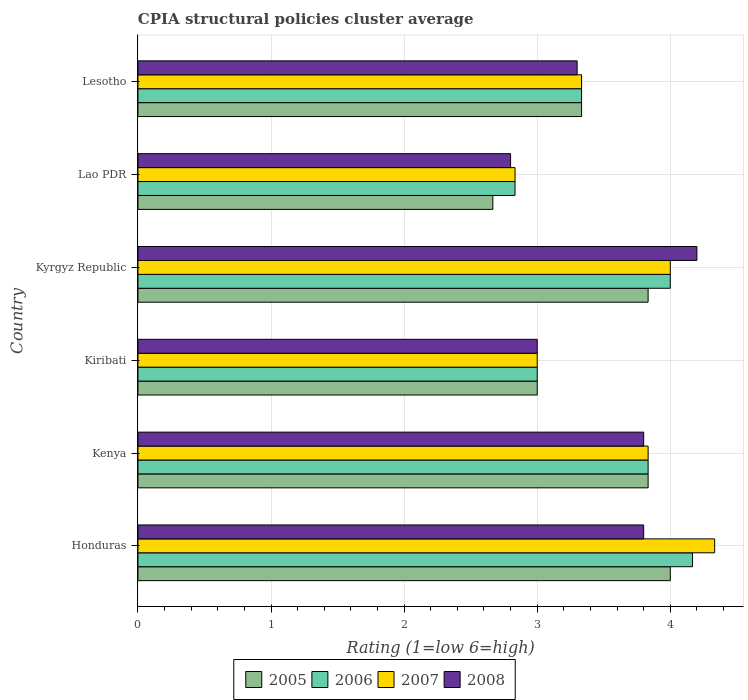How many different coloured bars are there?
Make the answer very short. 4. How many bars are there on the 4th tick from the bottom?
Keep it short and to the point. 4. What is the label of the 1st group of bars from the top?
Provide a succinct answer. Lesotho. In how many cases, is the number of bars for a given country not equal to the number of legend labels?
Your answer should be very brief. 0. What is the CPIA rating in 2007 in Kyrgyz Republic?
Provide a short and direct response. 4. Across all countries, what is the maximum CPIA rating in 2006?
Keep it short and to the point. 4.17. Across all countries, what is the minimum CPIA rating in 2007?
Offer a terse response. 2.83. In which country was the CPIA rating in 2006 maximum?
Give a very brief answer. Honduras. In which country was the CPIA rating in 2007 minimum?
Provide a short and direct response. Lao PDR. What is the total CPIA rating in 2007 in the graph?
Offer a very short reply. 21.33. What is the difference between the CPIA rating in 2006 in Kenya and that in Lesotho?
Give a very brief answer. 0.5. What is the average CPIA rating in 2005 per country?
Ensure brevity in your answer.  3.44. What is the difference between the CPIA rating in 2007 and CPIA rating in 2005 in Kenya?
Your answer should be compact. 0. What is the ratio of the CPIA rating in 2007 in Kiribati to that in Lao PDR?
Offer a very short reply. 1.06. Is the CPIA rating in 2008 in Honduras less than that in Kyrgyz Republic?
Your answer should be very brief. Yes. What is the difference between the highest and the second highest CPIA rating in 2005?
Your answer should be compact. 0.17. What is the difference between the highest and the lowest CPIA rating in 2006?
Keep it short and to the point. 1.33. Is the sum of the CPIA rating in 2005 in Kyrgyz Republic and Lao PDR greater than the maximum CPIA rating in 2008 across all countries?
Provide a succinct answer. Yes. Is it the case that in every country, the sum of the CPIA rating in 2006 and CPIA rating in 2008 is greater than the sum of CPIA rating in 2007 and CPIA rating in 2005?
Your answer should be compact. No. What does the 2nd bar from the top in Lesotho represents?
Keep it short and to the point. 2007. What does the 2nd bar from the bottom in Kenya represents?
Your answer should be compact. 2006. Is it the case that in every country, the sum of the CPIA rating in 2007 and CPIA rating in 2006 is greater than the CPIA rating in 2005?
Ensure brevity in your answer.  Yes. How many bars are there?
Make the answer very short. 24. Does the graph contain any zero values?
Give a very brief answer. No. Does the graph contain grids?
Give a very brief answer. Yes. What is the title of the graph?
Keep it short and to the point. CPIA structural policies cluster average. Does "2005" appear as one of the legend labels in the graph?
Offer a very short reply. Yes. What is the label or title of the X-axis?
Your answer should be very brief. Rating (1=low 6=high). What is the label or title of the Y-axis?
Provide a succinct answer. Country. What is the Rating (1=low 6=high) in 2006 in Honduras?
Provide a short and direct response. 4.17. What is the Rating (1=low 6=high) of 2007 in Honduras?
Make the answer very short. 4.33. What is the Rating (1=low 6=high) in 2008 in Honduras?
Your answer should be very brief. 3.8. What is the Rating (1=low 6=high) in 2005 in Kenya?
Ensure brevity in your answer.  3.83. What is the Rating (1=low 6=high) in 2006 in Kenya?
Offer a very short reply. 3.83. What is the Rating (1=low 6=high) of 2007 in Kenya?
Your answer should be compact. 3.83. What is the Rating (1=low 6=high) in 2005 in Kiribati?
Offer a very short reply. 3. What is the Rating (1=low 6=high) of 2007 in Kiribati?
Offer a very short reply. 3. What is the Rating (1=low 6=high) in 2005 in Kyrgyz Republic?
Your answer should be very brief. 3.83. What is the Rating (1=low 6=high) of 2006 in Kyrgyz Republic?
Offer a terse response. 4. What is the Rating (1=low 6=high) of 2005 in Lao PDR?
Make the answer very short. 2.67. What is the Rating (1=low 6=high) in 2006 in Lao PDR?
Give a very brief answer. 2.83. What is the Rating (1=low 6=high) in 2007 in Lao PDR?
Give a very brief answer. 2.83. What is the Rating (1=low 6=high) of 2005 in Lesotho?
Ensure brevity in your answer.  3.33. What is the Rating (1=low 6=high) in 2006 in Lesotho?
Ensure brevity in your answer.  3.33. What is the Rating (1=low 6=high) of 2007 in Lesotho?
Your answer should be very brief. 3.33. What is the Rating (1=low 6=high) in 2008 in Lesotho?
Offer a very short reply. 3.3. Across all countries, what is the maximum Rating (1=low 6=high) in 2005?
Offer a very short reply. 4. Across all countries, what is the maximum Rating (1=low 6=high) of 2006?
Offer a very short reply. 4.17. Across all countries, what is the maximum Rating (1=low 6=high) in 2007?
Offer a very short reply. 4.33. Across all countries, what is the minimum Rating (1=low 6=high) of 2005?
Provide a succinct answer. 2.67. Across all countries, what is the minimum Rating (1=low 6=high) of 2006?
Give a very brief answer. 2.83. Across all countries, what is the minimum Rating (1=low 6=high) of 2007?
Give a very brief answer. 2.83. What is the total Rating (1=low 6=high) in 2005 in the graph?
Your response must be concise. 20.67. What is the total Rating (1=low 6=high) in 2006 in the graph?
Provide a short and direct response. 21.17. What is the total Rating (1=low 6=high) in 2007 in the graph?
Offer a very short reply. 21.33. What is the total Rating (1=low 6=high) in 2008 in the graph?
Ensure brevity in your answer.  20.9. What is the difference between the Rating (1=low 6=high) of 2005 in Honduras and that in Kenya?
Your answer should be very brief. 0.17. What is the difference between the Rating (1=low 6=high) in 2007 in Honduras and that in Kenya?
Offer a terse response. 0.5. What is the difference between the Rating (1=low 6=high) in 2008 in Honduras and that in Kenya?
Keep it short and to the point. 0. What is the difference between the Rating (1=low 6=high) in 2007 in Honduras and that in Kiribati?
Keep it short and to the point. 1.33. What is the difference between the Rating (1=low 6=high) in 2006 in Honduras and that in Kyrgyz Republic?
Make the answer very short. 0.17. What is the difference between the Rating (1=low 6=high) in 2007 in Honduras and that in Kyrgyz Republic?
Your answer should be compact. 0.33. What is the difference between the Rating (1=low 6=high) of 2008 in Honduras and that in Kyrgyz Republic?
Keep it short and to the point. -0.4. What is the difference between the Rating (1=low 6=high) of 2005 in Honduras and that in Lao PDR?
Give a very brief answer. 1.33. What is the difference between the Rating (1=low 6=high) of 2007 in Honduras and that in Lao PDR?
Your answer should be compact. 1.5. What is the difference between the Rating (1=low 6=high) in 2006 in Honduras and that in Lesotho?
Ensure brevity in your answer.  0.83. What is the difference between the Rating (1=low 6=high) in 2008 in Honduras and that in Lesotho?
Provide a short and direct response. 0.5. What is the difference between the Rating (1=low 6=high) in 2005 in Kenya and that in Kiribati?
Your answer should be compact. 0.83. What is the difference between the Rating (1=low 6=high) of 2006 in Kenya and that in Kiribati?
Give a very brief answer. 0.83. What is the difference between the Rating (1=low 6=high) in 2007 in Kenya and that in Kiribati?
Your answer should be very brief. 0.83. What is the difference between the Rating (1=low 6=high) of 2008 in Kenya and that in Kiribati?
Your answer should be compact. 0.8. What is the difference between the Rating (1=low 6=high) in 2005 in Kenya and that in Kyrgyz Republic?
Your response must be concise. 0. What is the difference between the Rating (1=low 6=high) of 2007 in Kenya and that in Kyrgyz Republic?
Offer a very short reply. -0.17. What is the difference between the Rating (1=low 6=high) in 2008 in Kenya and that in Kyrgyz Republic?
Your response must be concise. -0.4. What is the difference between the Rating (1=low 6=high) of 2006 in Kenya and that in Lao PDR?
Give a very brief answer. 1. What is the difference between the Rating (1=low 6=high) of 2008 in Kiribati and that in Kyrgyz Republic?
Offer a very short reply. -1.2. What is the difference between the Rating (1=low 6=high) in 2007 in Kiribati and that in Lao PDR?
Give a very brief answer. 0.17. What is the difference between the Rating (1=low 6=high) of 2005 in Kiribati and that in Lesotho?
Ensure brevity in your answer.  -0.33. What is the difference between the Rating (1=low 6=high) in 2007 in Kiribati and that in Lesotho?
Offer a terse response. -0.33. What is the difference between the Rating (1=low 6=high) of 2008 in Kiribati and that in Lesotho?
Give a very brief answer. -0.3. What is the difference between the Rating (1=low 6=high) in 2007 in Kyrgyz Republic and that in Lao PDR?
Keep it short and to the point. 1.17. What is the difference between the Rating (1=low 6=high) in 2006 in Kyrgyz Republic and that in Lesotho?
Your answer should be compact. 0.67. What is the difference between the Rating (1=low 6=high) in 2007 in Kyrgyz Republic and that in Lesotho?
Provide a succinct answer. 0.67. What is the difference between the Rating (1=low 6=high) in 2008 in Kyrgyz Republic and that in Lesotho?
Give a very brief answer. 0.9. What is the difference between the Rating (1=low 6=high) of 2008 in Lao PDR and that in Lesotho?
Give a very brief answer. -0.5. What is the difference between the Rating (1=low 6=high) of 2005 in Honduras and the Rating (1=low 6=high) of 2006 in Kenya?
Make the answer very short. 0.17. What is the difference between the Rating (1=low 6=high) in 2005 in Honduras and the Rating (1=low 6=high) in 2007 in Kenya?
Your response must be concise. 0.17. What is the difference between the Rating (1=low 6=high) in 2005 in Honduras and the Rating (1=low 6=high) in 2008 in Kenya?
Give a very brief answer. 0.2. What is the difference between the Rating (1=low 6=high) of 2006 in Honduras and the Rating (1=low 6=high) of 2007 in Kenya?
Give a very brief answer. 0.33. What is the difference between the Rating (1=low 6=high) in 2006 in Honduras and the Rating (1=low 6=high) in 2008 in Kenya?
Offer a very short reply. 0.37. What is the difference between the Rating (1=low 6=high) of 2007 in Honduras and the Rating (1=low 6=high) of 2008 in Kenya?
Offer a terse response. 0.53. What is the difference between the Rating (1=low 6=high) of 2005 in Honduras and the Rating (1=low 6=high) of 2006 in Kiribati?
Ensure brevity in your answer.  1. What is the difference between the Rating (1=low 6=high) in 2005 in Honduras and the Rating (1=low 6=high) in 2006 in Kyrgyz Republic?
Offer a very short reply. 0. What is the difference between the Rating (1=low 6=high) of 2005 in Honduras and the Rating (1=low 6=high) of 2008 in Kyrgyz Republic?
Make the answer very short. -0.2. What is the difference between the Rating (1=low 6=high) in 2006 in Honduras and the Rating (1=low 6=high) in 2008 in Kyrgyz Republic?
Make the answer very short. -0.03. What is the difference between the Rating (1=low 6=high) in 2007 in Honduras and the Rating (1=low 6=high) in 2008 in Kyrgyz Republic?
Ensure brevity in your answer.  0.13. What is the difference between the Rating (1=low 6=high) in 2005 in Honduras and the Rating (1=low 6=high) in 2006 in Lao PDR?
Provide a succinct answer. 1.17. What is the difference between the Rating (1=low 6=high) in 2006 in Honduras and the Rating (1=low 6=high) in 2007 in Lao PDR?
Provide a succinct answer. 1.33. What is the difference between the Rating (1=low 6=high) of 2006 in Honduras and the Rating (1=low 6=high) of 2008 in Lao PDR?
Provide a succinct answer. 1.37. What is the difference between the Rating (1=low 6=high) of 2007 in Honduras and the Rating (1=low 6=high) of 2008 in Lao PDR?
Your response must be concise. 1.53. What is the difference between the Rating (1=low 6=high) in 2005 in Honduras and the Rating (1=low 6=high) in 2006 in Lesotho?
Provide a succinct answer. 0.67. What is the difference between the Rating (1=low 6=high) in 2006 in Honduras and the Rating (1=low 6=high) in 2008 in Lesotho?
Ensure brevity in your answer.  0.87. What is the difference between the Rating (1=low 6=high) of 2005 in Kenya and the Rating (1=low 6=high) of 2006 in Kiribati?
Keep it short and to the point. 0.83. What is the difference between the Rating (1=low 6=high) in 2005 in Kenya and the Rating (1=low 6=high) in 2007 in Kiribati?
Make the answer very short. 0.83. What is the difference between the Rating (1=low 6=high) in 2005 in Kenya and the Rating (1=low 6=high) in 2008 in Kiribati?
Keep it short and to the point. 0.83. What is the difference between the Rating (1=low 6=high) in 2006 in Kenya and the Rating (1=low 6=high) in 2008 in Kiribati?
Offer a terse response. 0.83. What is the difference between the Rating (1=low 6=high) in 2005 in Kenya and the Rating (1=low 6=high) in 2006 in Kyrgyz Republic?
Provide a short and direct response. -0.17. What is the difference between the Rating (1=low 6=high) of 2005 in Kenya and the Rating (1=low 6=high) of 2008 in Kyrgyz Republic?
Offer a very short reply. -0.37. What is the difference between the Rating (1=low 6=high) in 2006 in Kenya and the Rating (1=low 6=high) in 2008 in Kyrgyz Republic?
Ensure brevity in your answer.  -0.37. What is the difference between the Rating (1=low 6=high) of 2007 in Kenya and the Rating (1=low 6=high) of 2008 in Kyrgyz Republic?
Your response must be concise. -0.37. What is the difference between the Rating (1=low 6=high) of 2005 in Kenya and the Rating (1=low 6=high) of 2006 in Lao PDR?
Your answer should be very brief. 1. What is the difference between the Rating (1=low 6=high) of 2007 in Kenya and the Rating (1=low 6=high) of 2008 in Lao PDR?
Offer a terse response. 1.03. What is the difference between the Rating (1=low 6=high) of 2005 in Kenya and the Rating (1=low 6=high) of 2006 in Lesotho?
Your answer should be very brief. 0.5. What is the difference between the Rating (1=low 6=high) of 2005 in Kenya and the Rating (1=low 6=high) of 2007 in Lesotho?
Your answer should be very brief. 0.5. What is the difference between the Rating (1=low 6=high) of 2005 in Kenya and the Rating (1=low 6=high) of 2008 in Lesotho?
Your answer should be compact. 0.53. What is the difference between the Rating (1=low 6=high) of 2006 in Kenya and the Rating (1=low 6=high) of 2007 in Lesotho?
Provide a short and direct response. 0.5. What is the difference between the Rating (1=low 6=high) in 2006 in Kenya and the Rating (1=low 6=high) in 2008 in Lesotho?
Offer a terse response. 0.53. What is the difference between the Rating (1=low 6=high) in 2007 in Kenya and the Rating (1=low 6=high) in 2008 in Lesotho?
Make the answer very short. 0.53. What is the difference between the Rating (1=low 6=high) in 2005 in Kiribati and the Rating (1=low 6=high) in 2006 in Kyrgyz Republic?
Offer a terse response. -1. What is the difference between the Rating (1=low 6=high) in 2005 in Kiribati and the Rating (1=low 6=high) in 2007 in Kyrgyz Republic?
Give a very brief answer. -1. What is the difference between the Rating (1=low 6=high) of 2005 in Kiribati and the Rating (1=low 6=high) of 2008 in Kyrgyz Republic?
Give a very brief answer. -1.2. What is the difference between the Rating (1=low 6=high) in 2006 in Kiribati and the Rating (1=low 6=high) in 2008 in Kyrgyz Republic?
Your answer should be very brief. -1.2. What is the difference between the Rating (1=low 6=high) in 2007 in Kiribati and the Rating (1=low 6=high) in 2008 in Kyrgyz Republic?
Keep it short and to the point. -1.2. What is the difference between the Rating (1=low 6=high) in 2005 in Kiribati and the Rating (1=low 6=high) in 2008 in Lao PDR?
Offer a terse response. 0.2. What is the difference between the Rating (1=low 6=high) of 2006 in Kiribati and the Rating (1=low 6=high) of 2007 in Lao PDR?
Your answer should be very brief. 0.17. What is the difference between the Rating (1=low 6=high) in 2006 in Kiribati and the Rating (1=low 6=high) in 2008 in Lao PDR?
Ensure brevity in your answer.  0.2. What is the difference between the Rating (1=low 6=high) in 2007 in Kiribati and the Rating (1=low 6=high) in 2008 in Lao PDR?
Your answer should be very brief. 0.2. What is the difference between the Rating (1=low 6=high) of 2006 in Kiribati and the Rating (1=low 6=high) of 2008 in Lesotho?
Offer a terse response. -0.3. What is the difference between the Rating (1=low 6=high) in 2005 in Kyrgyz Republic and the Rating (1=low 6=high) in 2007 in Lao PDR?
Make the answer very short. 1. What is the difference between the Rating (1=low 6=high) of 2005 in Kyrgyz Republic and the Rating (1=low 6=high) of 2006 in Lesotho?
Your answer should be very brief. 0.5. What is the difference between the Rating (1=low 6=high) in 2005 in Kyrgyz Republic and the Rating (1=low 6=high) in 2007 in Lesotho?
Ensure brevity in your answer.  0.5. What is the difference between the Rating (1=low 6=high) of 2005 in Kyrgyz Republic and the Rating (1=low 6=high) of 2008 in Lesotho?
Ensure brevity in your answer.  0.53. What is the difference between the Rating (1=low 6=high) in 2006 in Kyrgyz Republic and the Rating (1=low 6=high) in 2007 in Lesotho?
Keep it short and to the point. 0.67. What is the difference between the Rating (1=low 6=high) of 2005 in Lao PDR and the Rating (1=low 6=high) of 2008 in Lesotho?
Keep it short and to the point. -0.63. What is the difference between the Rating (1=low 6=high) in 2006 in Lao PDR and the Rating (1=low 6=high) in 2008 in Lesotho?
Offer a terse response. -0.47. What is the difference between the Rating (1=low 6=high) of 2007 in Lao PDR and the Rating (1=low 6=high) of 2008 in Lesotho?
Keep it short and to the point. -0.47. What is the average Rating (1=low 6=high) of 2005 per country?
Offer a very short reply. 3.44. What is the average Rating (1=low 6=high) in 2006 per country?
Keep it short and to the point. 3.53. What is the average Rating (1=low 6=high) in 2007 per country?
Offer a very short reply. 3.56. What is the average Rating (1=low 6=high) in 2008 per country?
Give a very brief answer. 3.48. What is the difference between the Rating (1=low 6=high) of 2005 and Rating (1=low 6=high) of 2007 in Honduras?
Ensure brevity in your answer.  -0.33. What is the difference between the Rating (1=low 6=high) of 2006 and Rating (1=low 6=high) of 2008 in Honduras?
Make the answer very short. 0.37. What is the difference between the Rating (1=low 6=high) in 2007 and Rating (1=low 6=high) in 2008 in Honduras?
Provide a succinct answer. 0.53. What is the difference between the Rating (1=low 6=high) in 2005 and Rating (1=low 6=high) in 2006 in Kenya?
Ensure brevity in your answer.  0. What is the difference between the Rating (1=low 6=high) in 2005 and Rating (1=low 6=high) in 2007 in Kenya?
Offer a very short reply. 0. What is the difference between the Rating (1=low 6=high) of 2006 and Rating (1=low 6=high) of 2008 in Kenya?
Your answer should be compact. 0.03. What is the difference between the Rating (1=low 6=high) in 2007 and Rating (1=low 6=high) in 2008 in Kenya?
Your answer should be very brief. 0.03. What is the difference between the Rating (1=low 6=high) of 2006 and Rating (1=low 6=high) of 2007 in Kiribati?
Offer a very short reply. 0. What is the difference between the Rating (1=low 6=high) of 2006 and Rating (1=low 6=high) of 2008 in Kiribati?
Make the answer very short. 0. What is the difference between the Rating (1=low 6=high) in 2007 and Rating (1=low 6=high) in 2008 in Kiribati?
Keep it short and to the point. 0. What is the difference between the Rating (1=low 6=high) of 2005 and Rating (1=low 6=high) of 2006 in Kyrgyz Republic?
Your answer should be compact. -0.17. What is the difference between the Rating (1=low 6=high) of 2005 and Rating (1=low 6=high) of 2007 in Kyrgyz Republic?
Your answer should be very brief. -0.17. What is the difference between the Rating (1=low 6=high) of 2005 and Rating (1=low 6=high) of 2008 in Kyrgyz Republic?
Ensure brevity in your answer.  -0.37. What is the difference between the Rating (1=low 6=high) in 2005 and Rating (1=low 6=high) in 2007 in Lao PDR?
Ensure brevity in your answer.  -0.17. What is the difference between the Rating (1=low 6=high) in 2005 and Rating (1=low 6=high) in 2008 in Lao PDR?
Your answer should be very brief. -0.13. What is the difference between the Rating (1=low 6=high) in 2006 and Rating (1=low 6=high) in 2007 in Lao PDR?
Give a very brief answer. 0. What is the difference between the Rating (1=low 6=high) of 2006 and Rating (1=low 6=high) of 2008 in Lao PDR?
Provide a short and direct response. 0.03. What is the difference between the Rating (1=low 6=high) in 2005 and Rating (1=low 6=high) in 2007 in Lesotho?
Provide a succinct answer. 0. What is the difference between the Rating (1=low 6=high) of 2006 and Rating (1=low 6=high) of 2007 in Lesotho?
Offer a terse response. 0. What is the difference between the Rating (1=low 6=high) of 2006 and Rating (1=low 6=high) of 2008 in Lesotho?
Give a very brief answer. 0.03. What is the difference between the Rating (1=low 6=high) of 2007 and Rating (1=low 6=high) of 2008 in Lesotho?
Your answer should be compact. 0.03. What is the ratio of the Rating (1=low 6=high) of 2005 in Honduras to that in Kenya?
Offer a terse response. 1.04. What is the ratio of the Rating (1=low 6=high) in 2006 in Honduras to that in Kenya?
Keep it short and to the point. 1.09. What is the ratio of the Rating (1=low 6=high) in 2007 in Honduras to that in Kenya?
Your response must be concise. 1.13. What is the ratio of the Rating (1=low 6=high) in 2005 in Honduras to that in Kiribati?
Keep it short and to the point. 1.33. What is the ratio of the Rating (1=low 6=high) in 2006 in Honduras to that in Kiribati?
Provide a short and direct response. 1.39. What is the ratio of the Rating (1=low 6=high) of 2007 in Honduras to that in Kiribati?
Make the answer very short. 1.44. What is the ratio of the Rating (1=low 6=high) in 2008 in Honduras to that in Kiribati?
Ensure brevity in your answer.  1.27. What is the ratio of the Rating (1=low 6=high) in 2005 in Honduras to that in Kyrgyz Republic?
Ensure brevity in your answer.  1.04. What is the ratio of the Rating (1=low 6=high) of 2006 in Honduras to that in Kyrgyz Republic?
Provide a short and direct response. 1.04. What is the ratio of the Rating (1=low 6=high) of 2008 in Honduras to that in Kyrgyz Republic?
Provide a succinct answer. 0.9. What is the ratio of the Rating (1=low 6=high) of 2006 in Honduras to that in Lao PDR?
Offer a very short reply. 1.47. What is the ratio of the Rating (1=low 6=high) of 2007 in Honduras to that in Lao PDR?
Your answer should be compact. 1.53. What is the ratio of the Rating (1=low 6=high) of 2008 in Honduras to that in Lao PDR?
Provide a succinct answer. 1.36. What is the ratio of the Rating (1=low 6=high) of 2005 in Honduras to that in Lesotho?
Keep it short and to the point. 1.2. What is the ratio of the Rating (1=low 6=high) in 2008 in Honduras to that in Lesotho?
Offer a terse response. 1.15. What is the ratio of the Rating (1=low 6=high) in 2005 in Kenya to that in Kiribati?
Ensure brevity in your answer.  1.28. What is the ratio of the Rating (1=low 6=high) of 2006 in Kenya to that in Kiribati?
Give a very brief answer. 1.28. What is the ratio of the Rating (1=low 6=high) in 2007 in Kenya to that in Kiribati?
Keep it short and to the point. 1.28. What is the ratio of the Rating (1=low 6=high) of 2008 in Kenya to that in Kiribati?
Make the answer very short. 1.27. What is the ratio of the Rating (1=low 6=high) in 2005 in Kenya to that in Kyrgyz Republic?
Give a very brief answer. 1. What is the ratio of the Rating (1=low 6=high) of 2007 in Kenya to that in Kyrgyz Republic?
Keep it short and to the point. 0.96. What is the ratio of the Rating (1=low 6=high) in 2008 in Kenya to that in Kyrgyz Republic?
Offer a very short reply. 0.9. What is the ratio of the Rating (1=low 6=high) of 2005 in Kenya to that in Lao PDR?
Offer a very short reply. 1.44. What is the ratio of the Rating (1=low 6=high) in 2006 in Kenya to that in Lao PDR?
Keep it short and to the point. 1.35. What is the ratio of the Rating (1=low 6=high) of 2007 in Kenya to that in Lao PDR?
Your answer should be compact. 1.35. What is the ratio of the Rating (1=low 6=high) in 2008 in Kenya to that in Lao PDR?
Provide a succinct answer. 1.36. What is the ratio of the Rating (1=low 6=high) in 2005 in Kenya to that in Lesotho?
Your response must be concise. 1.15. What is the ratio of the Rating (1=low 6=high) of 2006 in Kenya to that in Lesotho?
Offer a terse response. 1.15. What is the ratio of the Rating (1=low 6=high) of 2007 in Kenya to that in Lesotho?
Your answer should be compact. 1.15. What is the ratio of the Rating (1=low 6=high) in 2008 in Kenya to that in Lesotho?
Make the answer very short. 1.15. What is the ratio of the Rating (1=low 6=high) of 2005 in Kiribati to that in Kyrgyz Republic?
Make the answer very short. 0.78. What is the ratio of the Rating (1=low 6=high) in 2006 in Kiribati to that in Kyrgyz Republic?
Your answer should be very brief. 0.75. What is the ratio of the Rating (1=low 6=high) of 2007 in Kiribati to that in Kyrgyz Republic?
Provide a succinct answer. 0.75. What is the ratio of the Rating (1=low 6=high) of 2008 in Kiribati to that in Kyrgyz Republic?
Keep it short and to the point. 0.71. What is the ratio of the Rating (1=low 6=high) of 2005 in Kiribati to that in Lao PDR?
Provide a short and direct response. 1.12. What is the ratio of the Rating (1=low 6=high) in 2006 in Kiribati to that in Lao PDR?
Your response must be concise. 1.06. What is the ratio of the Rating (1=low 6=high) of 2007 in Kiribati to that in Lao PDR?
Your answer should be compact. 1.06. What is the ratio of the Rating (1=low 6=high) in 2008 in Kiribati to that in Lao PDR?
Provide a succinct answer. 1.07. What is the ratio of the Rating (1=low 6=high) in 2005 in Kiribati to that in Lesotho?
Provide a short and direct response. 0.9. What is the ratio of the Rating (1=low 6=high) of 2006 in Kiribati to that in Lesotho?
Make the answer very short. 0.9. What is the ratio of the Rating (1=low 6=high) of 2007 in Kiribati to that in Lesotho?
Your response must be concise. 0.9. What is the ratio of the Rating (1=low 6=high) in 2008 in Kiribati to that in Lesotho?
Offer a very short reply. 0.91. What is the ratio of the Rating (1=low 6=high) in 2005 in Kyrgyz Republic to that in Lao PDR?
Make the answer very short. 1.44. What is the ratio of the Rating (1=low 6=high) of 2006 in Kyrgyz Republic to that in Lao PDR?
Your response must be concise. 1.41. What is the ratio of the Rating (1=low 6=high) of 2007 in Kyrgyz Republic to that in Lao PDR?
Your answer should be very brief. 1.41. What is the ratio of the Rating (1=low 6=high) in 2008 in Kyrgyz Republic to that in Lao PDR?
Provide a short and direct response. 1.5. What is the ratio of the Rating (1=low 6=high) in 2005 in Kyrgyz Republic to that in Lesotho?
Offer a terse response. 1.15. What is the ratio of the Rating (1=low 6=high) of 2006 in Kyrgyz Republic to that in Lesotho?
Offer a terse response. 1.2. What is the ratio of the Rating (1=low 6=high) of 2008 in Kyrgyz Republic to that in Lesotho?
Provide a succinct answer. 1.27. What is the ratio of the Rating (1=low 6=high) of 2005 in Lao PDR to that in Lesotho?
Keep it short and to the point. 0.8. What is the ratio of the Rating (1=low 6=high) of 2007 in Lao PDR to that in Lesotho?
Make the answer very short. 0.85. What is the ratio of the Rating (1=low 6=high) of 2008 in Lao PDR to that in Lesotho?
Your response must be concise. 0.85. What is the difference between the highest and the lowest Rating (1=low 6=high) of 2006?
Your answer should be very brief. 1.33. 